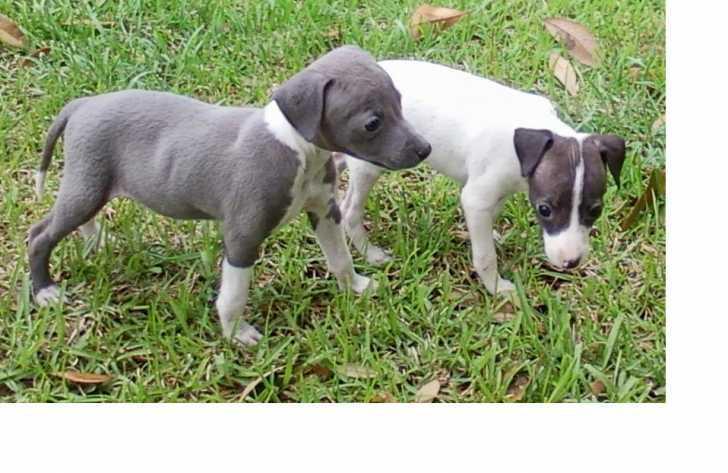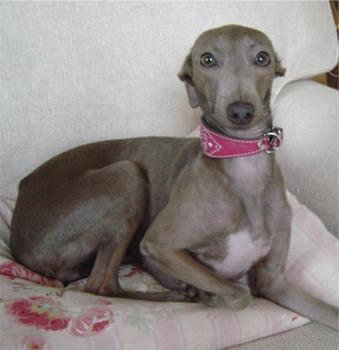The first image is the image on the left, the second image is the image on the right. Evaluate the accuracy of this statement regarding the images: "Left image contains two standing dogs, and right image contains one non-standing dog.". Is it true? Answer yes or no. Yes. The first image is the image on the left, the second image is the image on the right. For the images shown, is this caption "There are three dogs shown." true? Answer yes or no. Yes. 